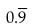Convert formula to latex. <formula><loc_0><loc_0><loc_500><loc_500>0 . \overline { 9 }</formula> 